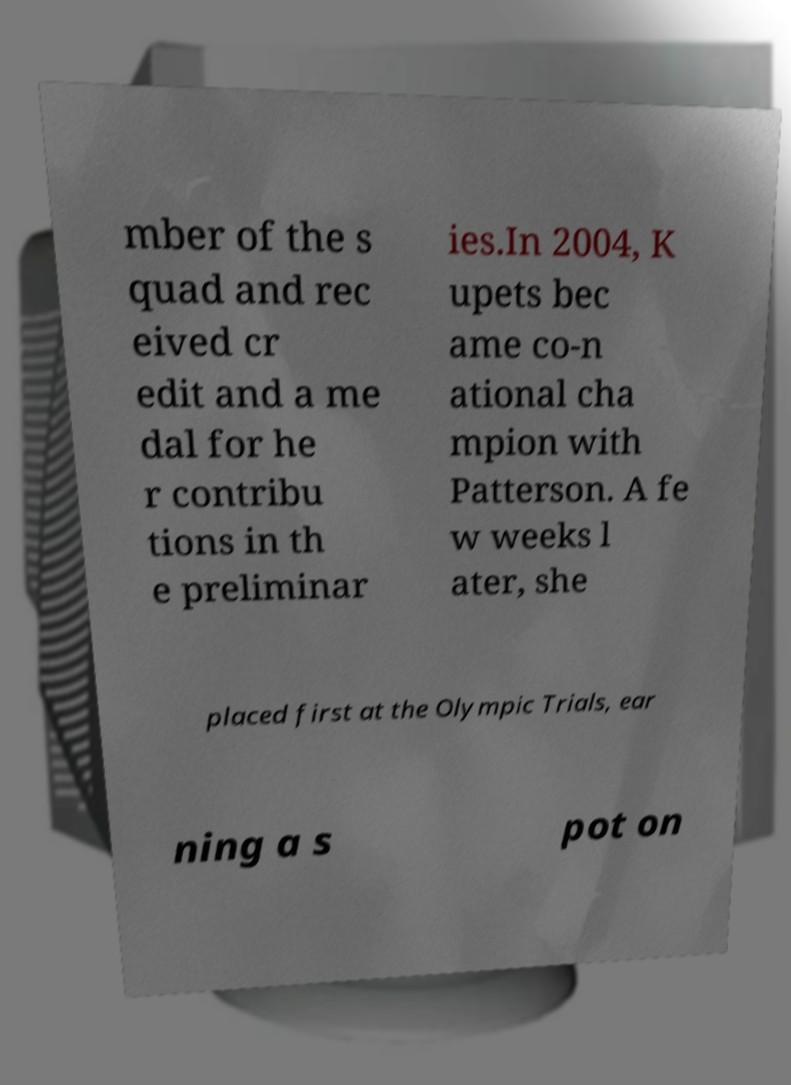There's text embedded in this image that I need extracted. Can you transcribe it verbatim? mber of the s quad and rec eived cr edit and a me dal for he r contribu tions in th e preliminar ies.In 2004, K upets bec ame co-n ational cha mpion with Patterson. A fe w weeks l ater, she placed first at the Olympic Trials, ear ning a s pot on 